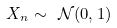<formula> <loc_0><loc_0><loc_500><loc_500>X _ { n } \sim \ { \mathcal { N } } ( 0 , 1 )</formula> 